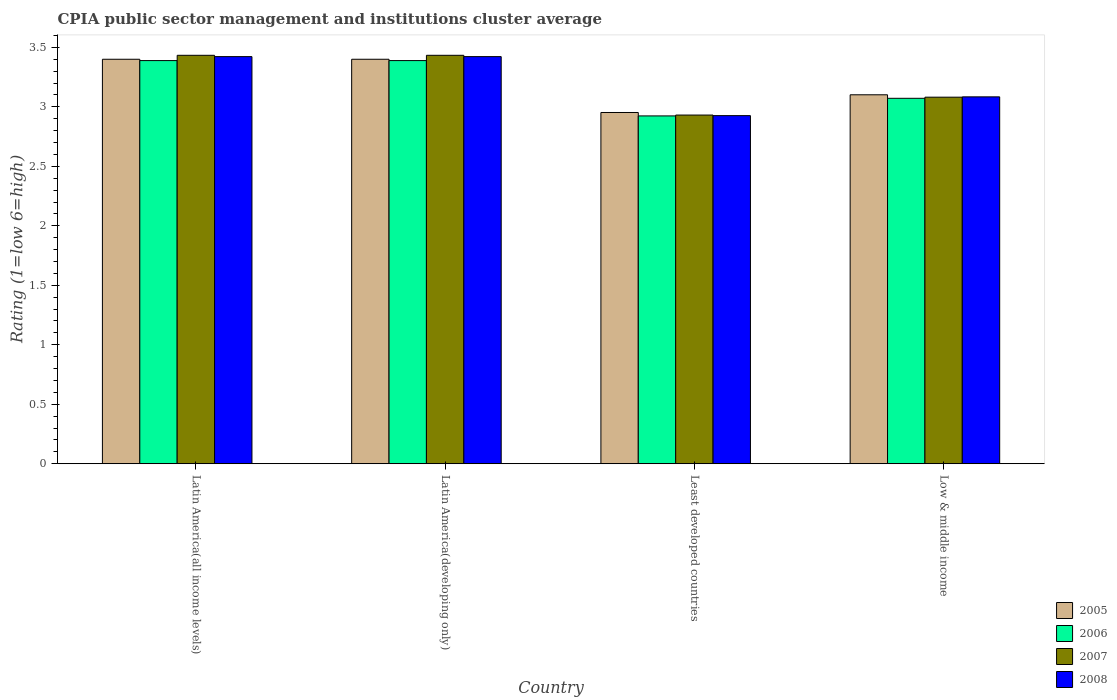How many different coloured bars are there?
Ensure brevity in your answer.  4. How many groups of bars are there?
Your response must be concise. 4. Are the number of bars per tick equal to the number of legend labels?
Ensure brevity in your answer.  Yes. Are the number of bars on each tick of the X-axis equal?
Offer a terse response. Yes. How many bars are there on the 1st tick from the left?
Ensure brevity in your answer.  4. How many bars are there on the 2nd tick from the right?
Make the answer very short. 4. What is the label of the 1st group of bars from the left?
Make the answer very short. Latin America(all income levels). What is the CPIA rating in 2008 in Latin America(developing only)?
Keep it short and to the point. 3.42. Across all countries, what is the maximum CPIA rating in 2008?
Provide a succinct answer. 3.42. Across all countries, what is the minimum CPIA rating in 2005?
Make the answer very short. 2.95. In which country was the CPIA rating in 2007 maximum?
Your response must be concise. Latin America(all income levels). In which country was the CPIA rating in 2007 minimum?
Give a very brief answer. Least developed countries. What is the total CPIA rating in 2008 in the graph?
Offer a very short reply. 12.85. What is the difference between the CPIA rating in 2006 in Latin America(all income levels) and that in Low & middle income?
Your answer should be very brief. 0.32. What is the difference between the CPIA rating in 2005 in Low & middle income and the CPIA rating in 2006 in Least developed countries?
Provide a succinct answer. 0.18. What is the average CPIA rating in 2007 per country?
Make the answer very short. 3.22. What is the difference between the CPIA rating of/in 2006 and CPIA rating of/in 2007 in Least developed countries?
Provide a succinct answer. -0.01. In how many countries, is the CPIA rating in 2005 greater than 1.8?
Your answer should be very brief. 4. What is the ratio of the CPIA rating in 2006 in Least developed countries to that in Low & middle income?
Make the answer very short. 0.95. Is the CPIA rating in 2005 in Latin America(developing only) less than that in Low & middle income?
Offer a very short reply. No. What is the difference between the highest and the second highest CPIA rating in 2008?
Your answer should be very brief. -0.34. What is the difference between the highest and the lowest CPIA rating in 2005?
Make the answer very short. 0.45. Is the sum of the CPIA rating in 2008 in Latin America(all income levels) and Least developed countries greater than the maximum CPIA rating in 2007 across all countries?
Provide a succinct answer. Yes. What does the 3rd bar from the right in Latin America(all income levels) represents?
Your answer should be very brief. 2006. How many bars are there?
Offer a very short reply. 16. Are all the bars in the graph horizontal?
Your answer should be very brief. No. How many countries are there in the graph?
Ensure brevity in your answer.  4. Are the values on the major ticks of Y-axis written in scientific E-notation?
Your answer should be compact. No. Does the graph contain any zero values?
Your answer should be very brief. No. Where does the legend appear in the graph?
Offer a very short reply. Bottom right. How many legend labels are there?
Provide a succinct answer. 4. What is the title of the graph?
Provide a succinct answer. CPIA public sector management and institutions cluster average. Does "2013" appear as one of the legend labels in the graph?
Your response must be concise. No. What is the label or title of the X-axis?
Provide a succinct answer. Country. What is the label or title of the Y-axis?
Give a very brief answer. Rating (1=low 6=high). What is the Rating (1=low 6=high) of 2006 in Latin America(all income levels)?
Give a very brief answer. 3.39. What is the Rating (1=low 6=high) in 2007 in Latin America(all income levels)?
Offer a terse response. 3.43. What is the Rating (1=low 6=high) in 2008 in Latin America(all income levels)?
Offer a terse response. 3.42. What is the Rating (1=low 6=high) of 2005 in Latin America(developing only)?
Your answer should be very brief. 3.4. What is the Rating (1=low 6=high) in 2006 in Latin America(developing only)?
Your response must be concise. 3.39. What is the Rating (1=low 6=high) of 2007 in Latin America(developing only)?
Keep it short and to the point. 3.43. What is the Rating (1=low 6=high) in 2008 in Latin America(developing only)?
Your answer should be compact. 3.42. What is the Rating (1=low 6=high) of 2005 in Least developed countries?
Your response must be concise. 2.95. What is the Rating (1=low 6=high) in 2006 in Least developed countries?
Provide a succinct answer. 2.92. What is the Rating (1=low 6=high) in 2007 in Least developed countries?
Keep it short and to the point. 2.93. What is the Rating (1=low 6=high) of 2008 in Least developed countries?
Make the answer very short. 2.93. What is the Rating (1=low 6=high) in 2005 in Low & middle income?
Make the answer very short. 3.1. What is the Rating (1=low 6=high) in 2006 in Low & middle income?
Offer a terse response. 3.07. What is the Rating (1=low 6=high) of 2007 in Low & middle income?
Give a very brief answer. 3.08. What is the Rating (1=low 6=high) of 2008 in Low & middle income?
Provide a short and direct response. 3.08. Across all countries, what is the maximum Rating (1=low 6=high) in 2006?
Keep it short and to the point. 3.39. Across all countries, what is the maximum Rating (1=low 6=high) in 2007?
Provide a succinct answer. 3.43. Across all countries, what is the maximum Rating (1=low 6=high) in 2008?
Keep it short and to the point. 3.42. Across all countries, what is the minimum Rating (1=low 6=high) of 2005?
Provide a succinct answer. 2.95. Across all countries, what is the minimum Rating (1=low 6=high) in 2006?
Keep it short and to the point. 2.92. Across all countries, what is the minimum Rating (1=low 6=high) of 2007?
Offer a very short reply. 2.93. Across all countries, what is the minimum Rating (1=low 6=high) in 2008?
Provide a short and direct response. 2.93. What is the total Rating (1=low 6=high) in 2005 in the graph?
Your answer should be compact. 12.85. What is the total Rating (1=low 6=high) in 2006 in the graph?
Make the answer very short. 12.77. What is the total Rating (1=low 6=high) in 2007 in the graph?
Keep it short and to the point. 12.88. What is the total Rating (1=low 6=high) of 2008 in the graph?
Offer a terse response. 12.85. What is the difference between the Rating (1=low 6=high) of 2005 in Latin America(all income levels) and that in Latin America(developing only)?
Your response must be concise. 0. What is the difference between the Rating (1=low 6=high) in 2006 in Latin America(all income levels) and that in Latin America(developing only)?
Ensure brevity in your answer.  0. What is the difference between the Rating (1=low 6=high) in 2008 in Latin America(all income levels) and that in Latin America(developing only)?
Your answer should be very brief. 0. What is the difference between the Rating (1=low 6=high) in 2005 in Latin America(all income levels) and that in Least developed countries?
Ensure brevity in your answer.  0.45. What is the difference between the Rating (1=low 6=high) in 2006 in Latin America(all income levels) and that in Least developed countries?
Make the answer very short. 0.47. What is the difference between the Rating (1=low 6=high) in 2007 in Latin America(all income levels) and that in Least developed countries?
Your answer should be very brief. 0.5. What is the difference between the Rating (1=low 6=high) in 2008 in Latin America(all income levels) and that in Least developed countries?
Your answer should be compact. 0.5. What is the difference between the Rating (1=low 6=high) in 2005 in Latin America(all income levels) and that in Low & middle income?
Offer a very short reply. 0.3. What is the difference between the Rating (1=low 6=high) of 2006 in Latin America(all income levels) and that in Low & middle income?
Provide a succinct answer. 0.32. What is the difference between the Rating (1=low 6=high) in 2007 in Latin America(all income levels) and that in Low & middle income?
Offer a very short reply. 0.35. What is the difference between the Rating (1=low 6=high) of 2008 in Latin America(all income levels) and that in Low & middle income?
Your response must be concise. 0.34. What is the difference between the Rating (1=low 6=high) in 2005 in Latin America(developing only) and that in Least developed countries?
Provide a succinct answer. 0.45. What is the difference between the Rating (1=low 6=high) of 2006 in Latin America(developing only) and that in Least developed countries?
Keep it short and to the point. 0.47. What is the difference between the Rating (1=low 6=high) of 2007 in Latin America(developing only) and that in Least developed countries?
Your response must be concise. 0.5. What is the difference between the Rating (1=low 6=high) of 2008 in Latin America(developing only) and that in Least developed countries?
Offer a very short reply. 0.5. What is the difference between the Rating (1=low 6=high) in 2005 in Latin America(developing only) and that in Low & middle income?
Ensure brevity in your answer.  0.3. What is the difference between the Rating (1=low 6=high) in 2006 in Latin America(developing only) and that in Low & middle income?
Keep it short and to the point. 0.32. What is the difference between the Rating (1=low 6=high) in 2007 in Latin America(developing only) and that in Low & middle income?
Keep it short and to the point. 0.35. What is the difference between the Rating (1=low 6=high) of 2008 in Latin America(developing only) and that in Low & middle income?
Your response must be concise. 0.34. What is the difference between the Rating (1=low 6=high) of 2005 in Least developed countries and that in Low & middle income?
Keep it short and to the point. -0.15. What is the difference between the Rating (1=low 6=high) in 2006 in Least developed countries and that in Low & middle income?
Offer a very short reply. -0.15. What is the difference between the Rating (1=low 6=high) in 2007 in Least developed countries and that in Low & middle income?
Your answer should be compact. -0.15. What is the difference between the Rating (1=low 6=high) of 2008 in Least developed countries and that in Low & middle income?
Make the answer very short. -0.16. What is the difference between the Rating (1=low 6=high) in 2005 in Latin America(all income levels) and the Rating (1=low 6=high) in 2006 in Latin America(developing only)?
Give a very brief answer. 0.01. What is the difference between the Rating (1=low 6=high) in 2005 in Latin America(all income levels) and the Rating (1=low 6=high) in 2007 in Latin America(developing only)?
Provide a short and direct response. -0.03. What is the difference between the Rating (1=low 6=high) of 2005 in Latin America(all income levels) and the Rating (1=low 6=high) of 2008 in Latin America(developing only)?
Provide a succinct answer. -0.02. What is the difference between the Rating (1=low 6=high) of 2006 in Latin America(all income levels) and the Rating (1=low 6=high) of 2007 in Latin America(developing only)?
Your answer should be compact. -0.04. What is the difference between the Rating (1=low 6=high) in 2006 in Latin America(all income levels) and the Rating (1=low 6=high) in 2008 in Latin America(developing only)?
Offer a very short reply. -0.03. What is the difference between the Rating (1=low 6=high) in 2007 in Latin America(all income levels) and the Rating (1=low 6=high) in 2008 in Latin America(developing only)?
Provide a succinct answer. 0.01. What is the difference between the Rating (1=low 6=high) in 2005 in Latin America(all income levels) and the Rating (1=low 6=high) in 2006 in Least developed countries?
Give a very brief answer. 0.48. What is the difference between the Rating (1=low 6=high) in 2005 in Latin America(all income levels) and the Rating (1=low 6=high) in 2007 in Least developed countries?
Give a very brief answer. 0.47. What is the difference between the Rating (1=low 6=high) in 2005 in Latin America(all income levels) and the Rating (1=low 6=high) in 2008 in Least developed countries?
Offer a terse response. 0.47. What is the difference between the Rating (1=low 6=high) in 2006 in Latin America(all income levels) and the Rating (1=low 6=high) in 2007 in Least developed countries?
Your response must be concise. 0.46. What is the difference between the Rating (1=low 6=high) of 2006 in Latin America(all income levels) and the Rating (1=low 6=high) of 2008 in Least developed countries?
Make the answer very short. 0.46. What is the difference between the Rating (1=low 6=high) of 2007 in Latin America(all income levels) and the Rating (1=low 6=high) of 2008 in Least developed countries?
Provide a short and direct response. 0.51. What is the difference between the Rating (1=low 6=high) of 2005 in Latin America(all income levels) and the Rating (1=low 6=high) of 2006 in Low & middle income?
Keep it short and to the point. 0.33. What is the difference between the Rating (1=low 6=high) of 2005 in Latin America(all income levels) and the Rating (1=low 6=high) of 2007 in Low & middle income?
Offer a terse response. 0.32. What is the difference between the Rating (1=low 6=high) of 2005 in Latin America(all income levels) and the Rating (1=low 6=high) of 2008 in Low & middle income?
Your answer should be very brief. 0.32. What is the difference between the Rating (1=low 6=high) in 2006 in Latin America(all income levels) and the Rating (1=low 6=high) in 2007 in Low & middle income?
Keep it short and to the point. 0.31. What is the difference between the Rating (1=low 6=high) of 2006 in Latin America(all income levels) and the Rating (1=low 6=high) of 2008 in Low & middle income?
Your answer should be very brief. 0.3. What is the difference between the Rating (1=low 6=high) in 2007 in Latin America(all income levels) and the Rating (1=low 6=high) in 2008 in Low & middle income?
Offer a very short reply. 0.35. What is the difference between the Rating (1=low 6=high) of 2005 in Latin America(developing only) and the Rating (1=low 6=high) of 2006 in Least developed countries?
Provide a short and direct response. 0.48. What is the difference between the Rating (1=low 6=high) of 2005 in Latin America(developing only) and the Rating (1=low 6=high) of 2007 in Least developed countries?
Provide a short and direct response. 0.47. What is the difference between the Rating (1=low 6=high) of 2005 in Latin America(developing only) and the Rating (1=low 6=high) of 2008 in Least developed countries?
Give a very brief answer. 0.47. What is the difference between the Rating (1=low 6=high) of 2006 in Latin America(developing only) and the Rating (1=low 6=high) of 2007 in Least developed countries?
Ensure brevity in your answer.  0.46. What is the difference between the Rating (1=low 6=high) of 2006 in Latin America(developing only) and the Rating (1=low 6=high) of 2008 in Least developed countries?
Your answer should be very brief. 0.46. What is the difference between the Rating (1=low 6=high) in 2007 in Latin America(developing only) and the Rating (1=low 6=high) in 2008 in Least developed countries?
Provide a succinct answer. 0.51. What is the difference between the Rating (1=low 6=high) in 2005 in Latin America(developing only) and the Rating (1=low 6=high) in 2006 in Low & middle income?
Ensure brevity in your answer.  0.33. What is the difference between the Rating (1=low 6=high) in 2005 in Latin America(developing only) and the Rating (1=low 6=high) in 2007 in Low & middle income?
Ensure brevity in your answer.  0.32. What is the difference between the Rating (1=low 6=high) in 2005 in Latin America(developing only) and the Rating (1=low 6=high) in 2008 in Low & middle income?
Offer a very short reply. 0.32. What is the difference between the Rating (1=low 6=high) in 2006 in Latin America(developing only) and the Rating (1=low 6=high) in 2007 in Low & middle income?
Your answer should be compact. 0.31. What is the difference between the Rating (1=low 6=high) of 2006 in Latin America(developing only) and the Rating (1=low 6=high) of 2008 in Low & middle income?
Ensure brevity in your answer.  0.3. What is the difference between the Rating (1=low 6=high) of 2007 in Latin America(developing only) and the Rating (1=low 6=high) of 2008 in Low & middle income?
Offer a very short reply. 0.35. What is the difference between the Rating (1=low 6=high) of 2005 in Least developed countries and the Rating (1=low 6=high) of 2006 in Low & middle income?
Keep it short and to the point. -0.12. What is the difference between the Rating (1=low 6=high) of 2005 in Least developed countries and the Rating (1=low 6=high) of 2007 in Low & middle income?
Provide a succinct answer. -0.13. What is the difference between the Rating (1=low 6=high) in 2005 in Least developed countries and the Rating (1=low 6=high) in 2008 in Low & middle income?
Offer a very short reply. -0.13. What is the difference between the Rating (1=low 6=high) in 2006 in Least developed countries and the Rating (1=low 6=high) in 2007 in Low & middle income?
Ensure brevity in your answer.  -0.16. What is the difference between the Rating (1=low 6=high) in 2006 in Least developed countries and the Rating (1=low 6=high) in 2008 in Low & middle income?
Give a very brief answer. -0.16. What is the difference between the Rating (1=low 6=high) in 2007 in Least developed countries and the Rating (1=low 6=high) in 2008 in Low & middle income?
Your response must be concise. -0.15. What is the average Rating (1=low 6=high) of 2005 per country?
Your answer should be compact. 3.21. What is the average Rating (1=low 6=high) in 2006 per country?
Give a very brief answer. 3.19. What is the average Rating (1=low 6=high) in 2007 per country?
Give a very brief answer. 3.22. What is the average Rating (1=low 6=high) in 2008 per country?
Keep it short and to the point. 3.21. What is the difference between the Rating (1=low 6=high) in 2005 and Rating (1=low 6=high) in 2006 in Latin America(all income levels)?
Give a very brief answer. 0.01. What is the difference between the Rating (1=low 6=high) in 2005 and Rating (1=low 6=high) in 2007 in Latin America(all income levels)?
Offer a terse response. -0.03. What is the difference between the Rating (1=low 6=high) of 2005 and Rating (1=low 6=high) of 2008 in Latin America(all income levels)?
Your response must be concise. -0.02. What is the difference between the Rating (1=low 6=high) of 2006 and Rating (1=low 6=high) of 2007 in Latin America(all income levels)?
Offer a very short reply. -0.04. What is the difference between the Rating (1=low 6=high) of 2006 and Rating (1=low 6=high) of 2008 in Latin America(all income levels)?
Offer a very short reply. -0.03. What is the difference between the Rating (1=low 6=high) in 2007 and Rating (1=low 6=high) in 2008 in Latin America(all income levels)?
Offer a terse response. 0.01. What is the difference between the Rating (1=low 6=high) in 2005 and Rating (1=low 6=high) in 2006 in Latin America(developing only)?
Make the answer very short. 0.01. What is the difference between the Rating (1=low 6=high) of 2005 and Rating (1=low 6=high) of 2007 in Latin America(developing only)?
Ensure brevity in your answer.  -0.03. What is the difference between the Rating (1=low 6=high) in 2005 and Rating (1=low 6=high) in 2008 in Latin America(developing only)?
Your answer should be compact. -0.02. What is the difference between the Rating (1=low 6=high) of 2006 and Rating (1=low 6=high) of 2007 in Latin America(developing only)?
Your answer should be very brief. -0.04. What is the difference between the Rating (1=low 6=high) of 2006 and Rating (1=low 6=high) of 2008 in Latin America(developing only)?
Keep it short and to the point. -0.03. What is the difference between the Rating (1=low 6=high) of 2007 and Rating (1=low 6=high) of 2008 in Latin America(developing only)?
Your response must be concise. 0.01. What is the difference between the Rating (1=low 6=high) of 2005 and Rating (1=low 6=high) of 2006 in Least developed countries?
Your response must be concise. 0.03. What is the difference between the Rating (1=low 6=high) of 2005 and Rating (1=low 6=high) of 2007 in Least developed countries?
Give a very brief answer. 0.02. What is the difference between the Rating (1=low 6=high) of 2005 and Rating (1=low 6=high) of 2008 in Least developed countries?
Provide a short and direct response. 0.03. What is the difference between the Rating (1=low 6=high) in 2006 and Rating (1=low 6=high) in 2007 in Least developed countries?
Keep it short and to the point. -0.01. What is the difference between the Rating (1=low 6=high) in 2006 and Rating (1=low 6=high) in 2008 in Least developed countries?
Offer a very short reply. -0. What is the difference between the Rating (1=low 6=high) of 2007 and Rating (1=low 6=high) of 2008 in Least developed countries?
Your answer should be compact. 0. What is the difference between the Rating (1=low 6=high) in 2005 and Rating (1=low 6=high) in 2006 in Low & middle income?
Give a very brief answer. 0.03. What is the difference between the Rating (1=low 6=high) of 2005 and Rating (1=low 6=high) of 2008 in Low & middle income?
Provide a succinct answer. 0.02. What is the difference between the Rating (1=low 6=high) in 2006 and Rating (1=low 6=high) in 2007 in Low & middle income?
Offer a terse response. -0.01. What is the difference between the Rating (1=low 6=high) of 2006 and Rating (1=low 6=high) of 2008 in Low & middle income?
Offer a terse response. -0.01. What is the difference between the Rating (1=low 6=high) in 2007 and Rating (1=low 6=high) in 2008 in Low & middle income?
Give a very brief answer. -0. What is the ratio of the Rating (1=low 6=high) in 2005 in Latin America(all income levels) to that in Latin America(developing only)?
Provide a short and direct response. 1. What is the ratio of the Rating (1=low 6=high) of 2007 in Latin America(all income levels) to that in Latin America(developing only)?
Your answer should be very brief. 1. What is the ratio of the Rating (1=low 6=high) in 2005 in Latin America(all income levels) to that in Least developed countries?
Your answer should be very brief. 1.15. What is the ratio of the Rating (1=low 6=high) in 2006 in Latin America(all income levels) to that in Least developed countries?
Give a very brief answer. 1.16. What is the ratio of the Rating (1=low 6=high) of 2007 in Latin America(all income levels) to that in Least developed countries?
Your answer should be compact. 1.17. What is the ratio of the Rating (1=low 6=high) of 2008 in Latin America(all income levels) to that in Least developed countries?
Keep it short and to the point. 1.17. What is the ratio of the Rating (1=low 6=high) in 2005 in Latin America(all income levels) to that in Low & middle income?
Provide a succinct answer. 1.1. What is the ratio of the Rating (1=low 6=high) of 2006 in Latin America(all income levels) to that in Low & middle income?
Ensure brevity in your answer.  1.1. What is the ratio of the Rating (1=low 6=high) of 2007 in Latin America(all income levels) to that in Low & middle income?
Your answer should be compact. 1.11. What is the ratio of the Rating (1=low 6=high) in 2008 in Latin America(all income levels) to that in Low & middle income?
Offer a terse response. 1.11. What is the ratio of the Rating (1=low 6=high) in 2005 in Latin America(developing only) to that in Least developed countries?
Your answer should be compact. 1.15. What is the ratio of the Rating (1=low 6=high) in 2006 in Latin America(developing only) to that in Least developed countries?
Give a very brief answer. 1.16. What is the ratio of the Rating (1=low 6=high) of 2007 in Latin America(developing only) to that in Least developed countries?
Your answer should be very brief. 1.17. What is the ratio of the Rating (1=low 6=high) of 2008 in Latin America(developing only) to that in Least developed countries?
Offer a very short reply. 1.17. What is the ratio of the Rating (1=low 6=high) in 2005 in Latin America(developing only) to that in Low & middle income?
Offer a very short reply. 1.1. What is the ratio of the Rating (1=low 6=high) of 2006 in Latin America(developing only) to that in Low & middle income?
Your answer should be compact. 1.1. What is the ratio of the Rating (1=low 6=high) of 2007 in Latin America(developing only) to that in Low & middle income?
Make the answer very short. 1.11. What is the ratio of the Rating (1=low 6=high) in 2008 in Latin America(developing only) to that in Low & middle income?
Keep it short and to the point. 1.11. What is the ratio of the Rating (1=low 6=high) of 2005 in Least developed countries to that in Low & middle income?
Offer a terse response. 0.95. What is the ratio of the Rating (1=low 6=high) of 2006 in Least developed countries to that in Low & middle income?
Ensure brevity in your answer.  0.95. What is the ratio of the Rating (1=low 6=high) in 2007 in Least developed countries to that in Low & middle income?
Give a very brief answer. 0.95. What is the ratio of the Rating (1=low 6=high) of 2008 in Least developed countries to that in Low & middle income?
Give a very brief answer. 0.95. What is the difference between the highest and the second highest Rating (1=low 6=high) of 2008?
Your answer should be compact. 0. What is the difference between the highest and the lowest Rating (1=low 6=high) of 2005?
Keep it short and to the point. 0.45. What is the difference between the highest and the lowest Rating (1=low 6=high) of 2006?
Offer a very short reply. 0.47. What is the difference between the highest and the lowest Rating (1=low 6=high) in 2007?
Keep it short and to the point. 0.5. What is the difference between the highest and the lowest Rating (1=low 6=high) in 2008?
Provide a short and direct response. 0.5. 